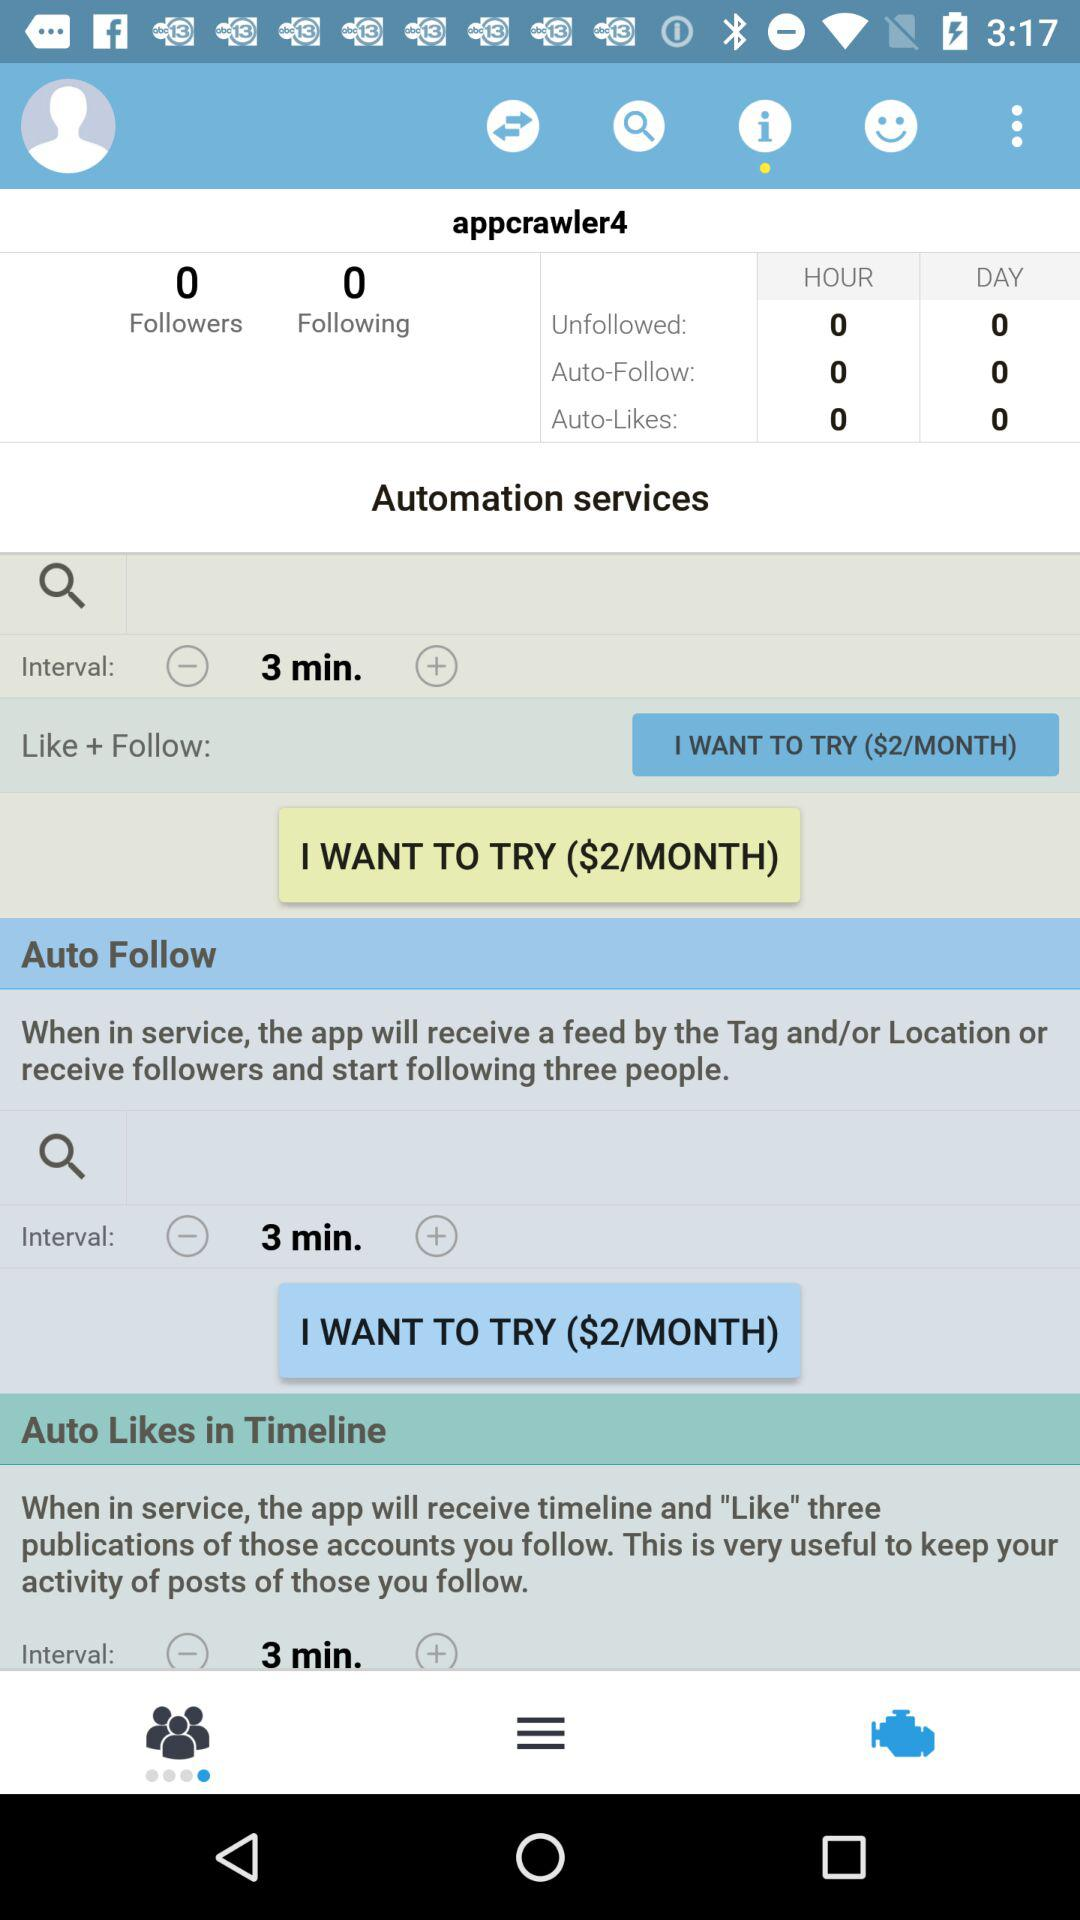How many people are following appcrawler4? There are 0 people following the appcrawler4. 